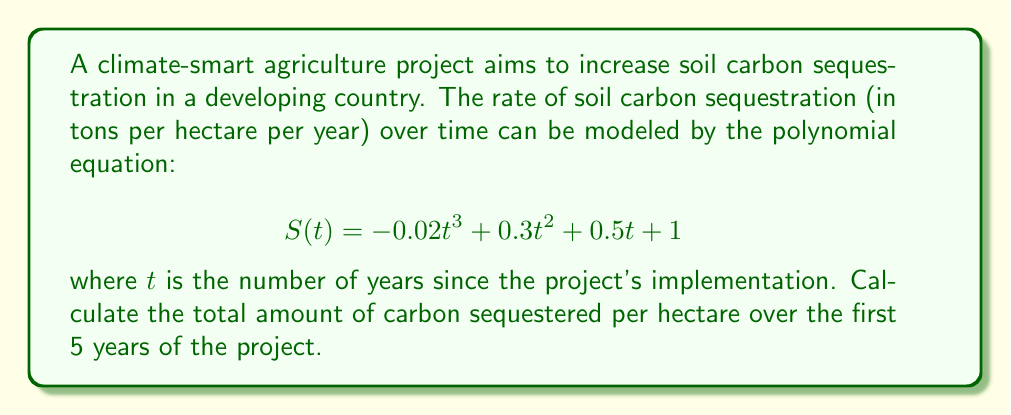Solve this math problem. To find the total amount of carbon sequestered over the first 5 years, we need to calculate the definite integral of the sequestration rate function from $t=0$ to $t=5$. This will give us the area under the curve, which represents the cumulative carbon sequestered.

1) The indefinite integral of $S(t)$ is:

   $$ \int S(t) dt = -0.005t^4 + 0.1t^3 + 0.25t^2 + t + C $$

2) Now, we need to evaluate this integral from 0 to 5:

   $$ \int_0^5 S(t) dt = [-0.005t^4 + 0.1t^3 + 0.25t^2 + t]_0^5 $$

3) Substitute $t=5$ and $t=0$:

   $$ = (-0.005(5^4) + 0.1(5^3) + 0.25(5^2) + 5) - (-0.005(0^4) + 0.1(0^3) + 0.25(0^2) + 0) $$

4) Simplify:

   $$ = (-3.125 + 12.5 + 6.25 + 5) - 0 $$
   $$ = 20.625 - 0 = 20.625 $$

Therefore, the total amount of carbon sequestered per hectare over the first 5 years is 20.625 tons.
Answer: 20.625 tons per hectare 